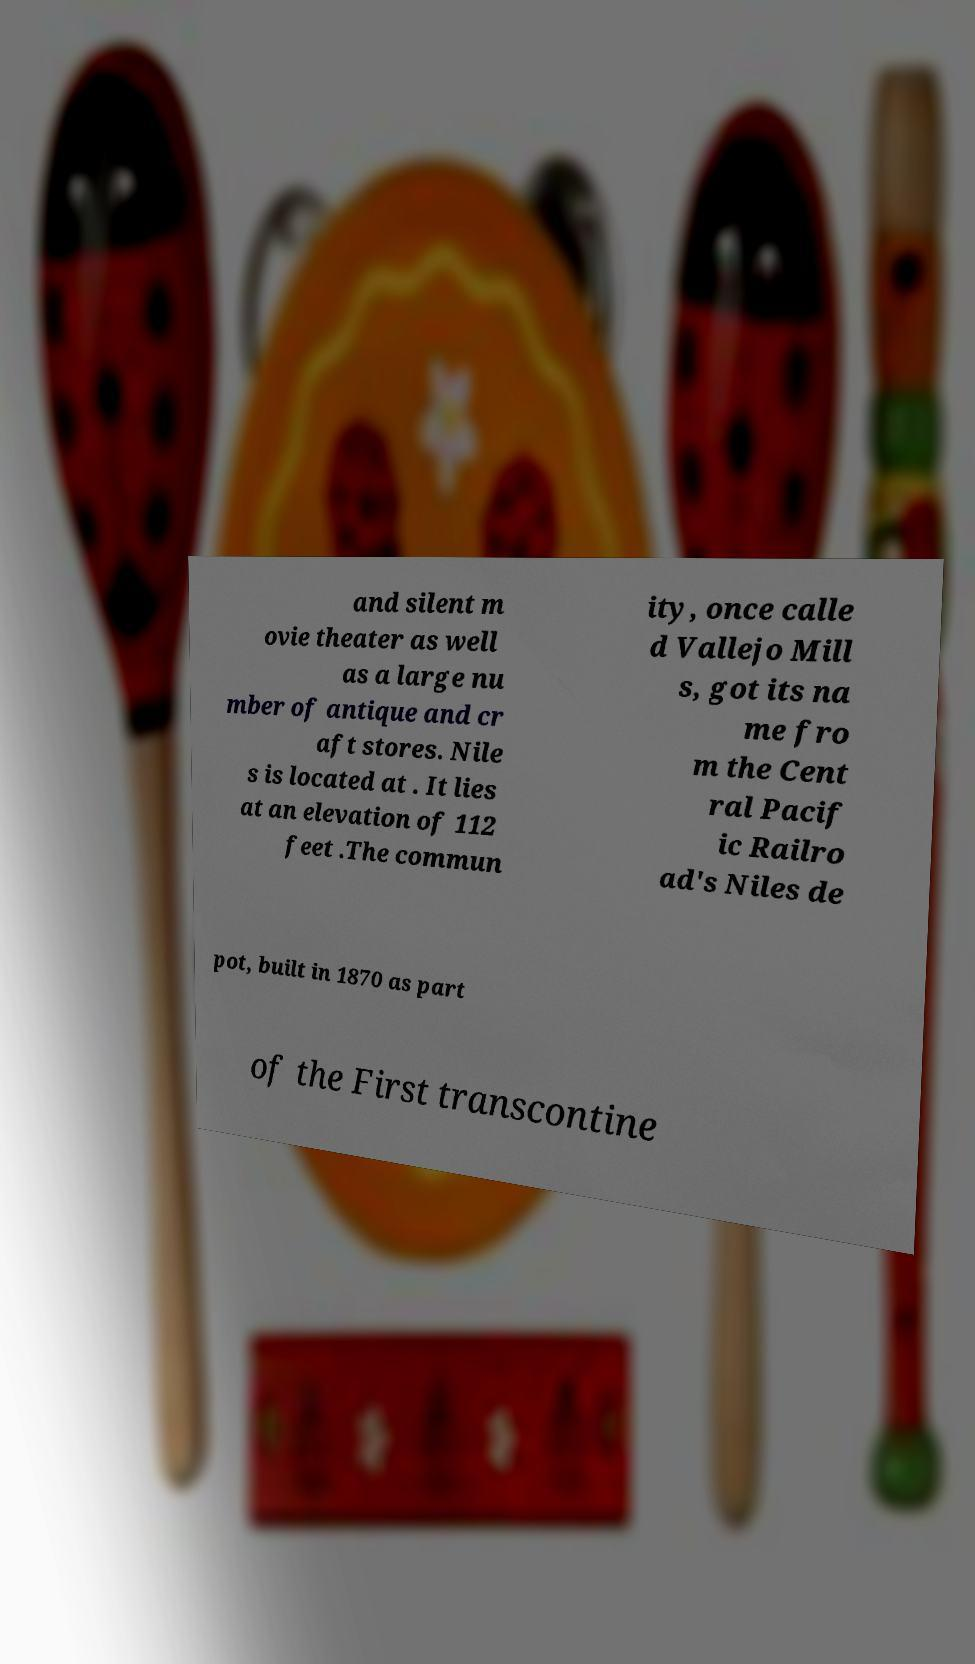For documentation purposes, I need the text within this image transcribed. Could you provide that? and silent m ovie theater as well as a large nu mber of antique and cr aft stores. Nile s is located at . It lies at an elevation of 112 feet .The commun ity, once calle d Vallejo Mill s, got its na me fro m the Cent ral Pacif ic Railro ad's Niles de pot, built in 1870 as part of the First transcontine 